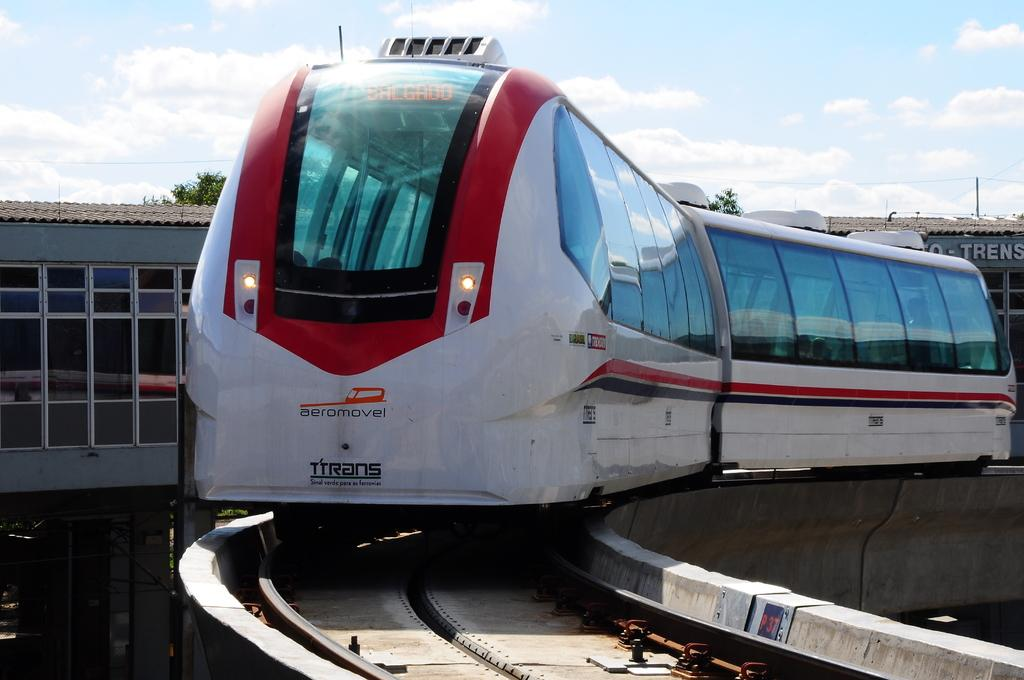What is the main subject of the image? The main subject of the image is a locomotive on the track. What else can be seen in the image besides the locomotive? Buildings, trees, name boards, and the sky are visible in the image. Can you describe the sky in the image? The sky is visible in the image, and clouds are present in it. Can you see your dad kissing a root in the image? There is no person, including your dad, nor any root present in the image. 